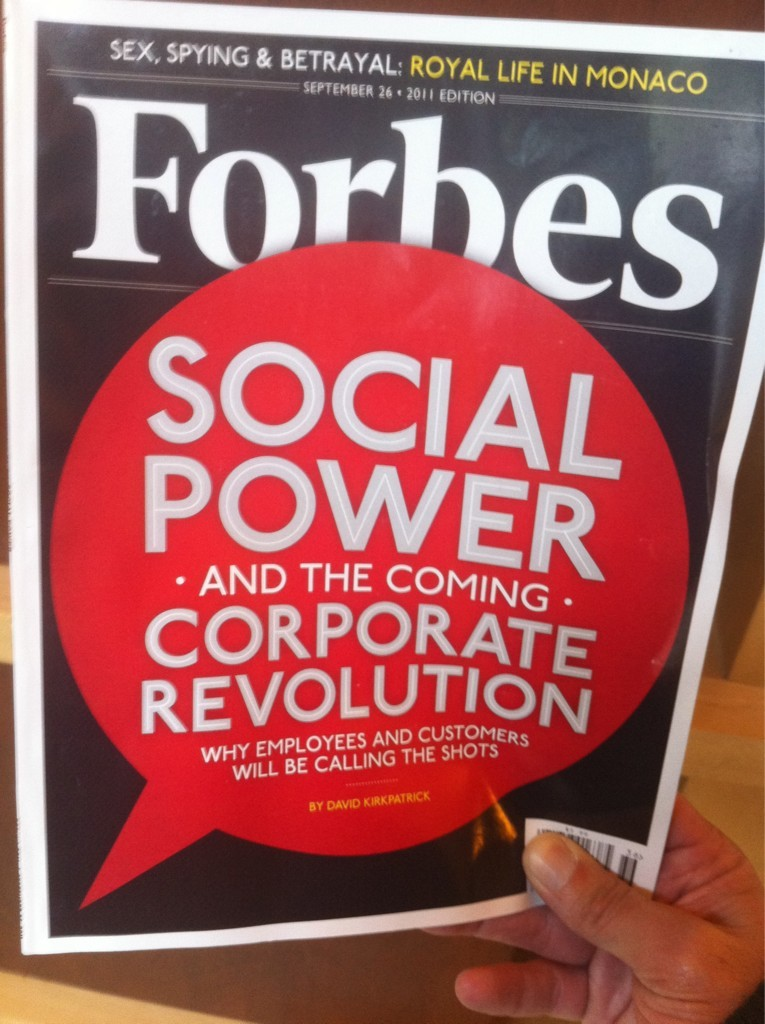Explain the visual content of the image in great detail. The image displays the cover of the Forbes magazine from September 26, 2011. It prominently features a large red speech bubble that contains the main headline: 'Social Power...and the coming corporate revolution.' This headline suggests an examination of social media's potential to transform corporate power structures. Below the headline, additional text elaborates on the theme, indicating that employees and customers will increasingly influence company decisions. The cover also teases other articles with titillating subjects such as 'Sex, Spying & Betrayal: Royal Life in Monaco,' promising insider insights into the tumultuous personal affairs of Monaco's royalty. To visually anchor these themes, a hand is shown grasping the magazine, perhaps symbolizing the reader's active engagement with these transformative ideas. This image effectively mirrors the magazine's focus on dynamic social changes affecting hierarchical and personal domains. 